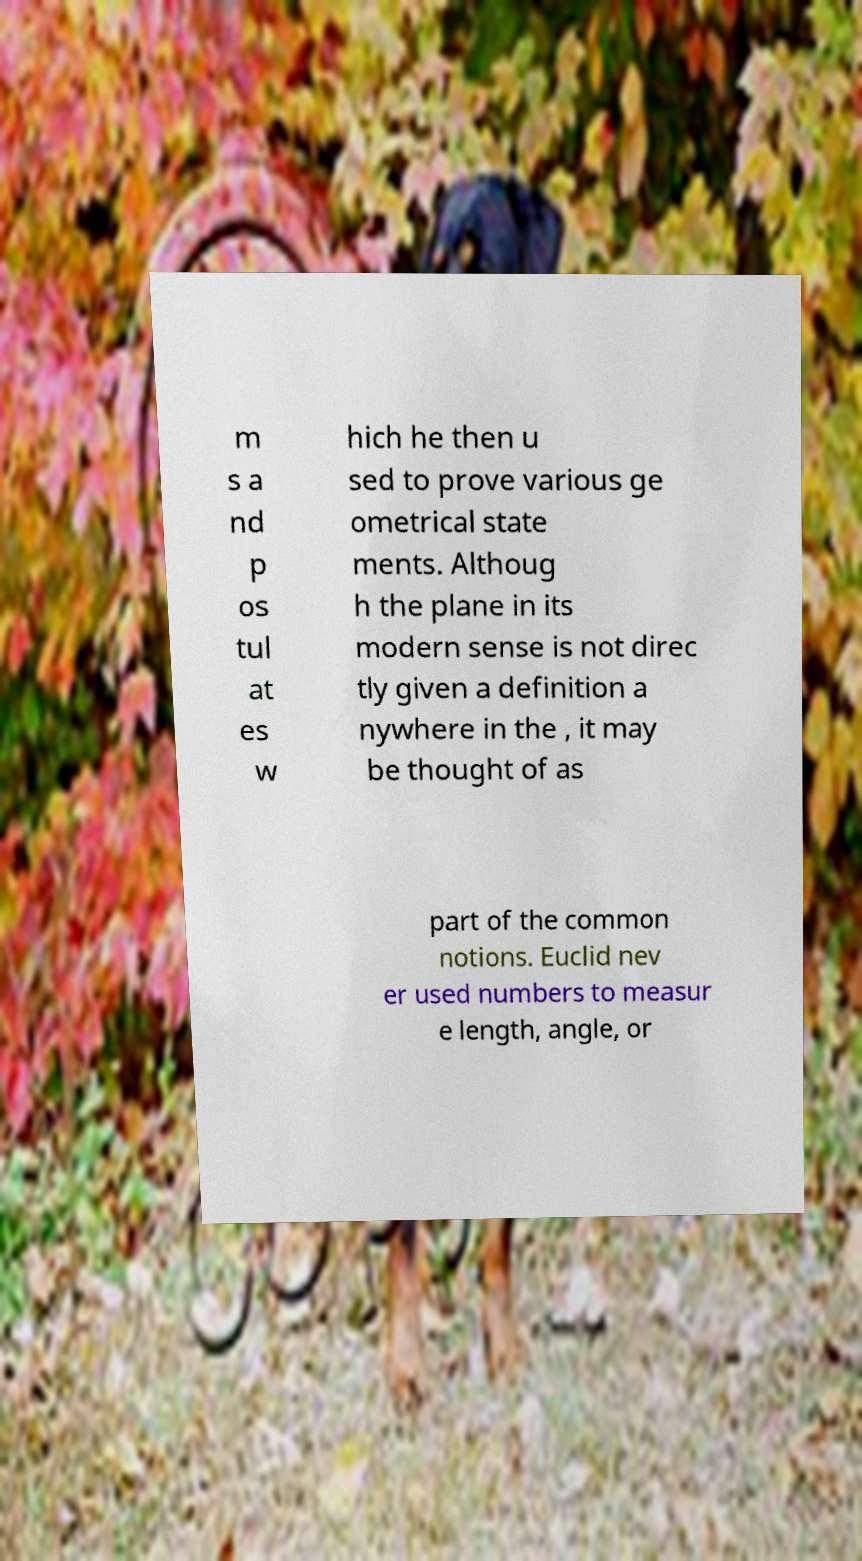Can you accurately transcribe the text from the provided image for me? m s a nd p os tul at es w hich he then u sed to prove various ge ometrical state ments. Althoug h the plane in its modern sense is not direc tly given a definition a nywhere in the , it may be thought of as part of the common notions. Euclid nev er used numbers to measur e length, angle, or 